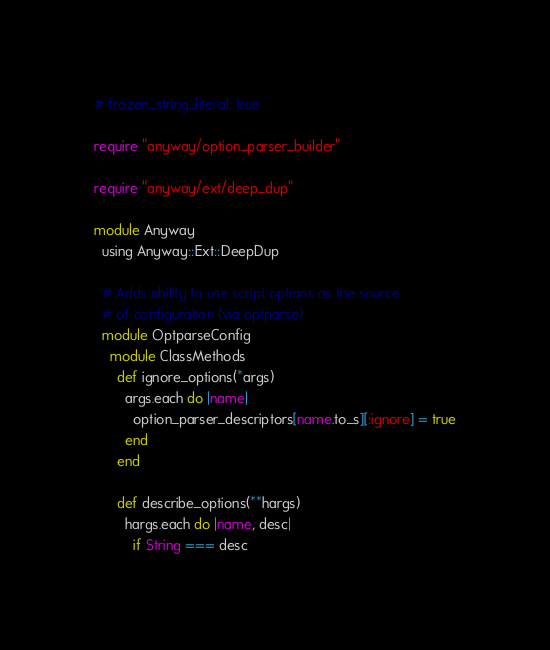Convert code to text. <code><loc_0><loc_0><loc_500><loc_500><_Ruby_># frozen_string_literal: true

require "anyway/option_parser_builder"

require "anyway/ext/deep_dup"

module Anyway
  using Anyway::Ext::DeepDup

  # Adds ability to use script options as the source
  # of configuration (via optparse)
  module OptparseConfig
    module ClassMethods
      def ignore_options(*args)
        args.each do |name|
          option_parser_descriptors[name.to_s][:ignore] = true
        end
      end

      def describe_options(**hargs)
        hargs.each do |name, desc|
          if String === desc</code> 